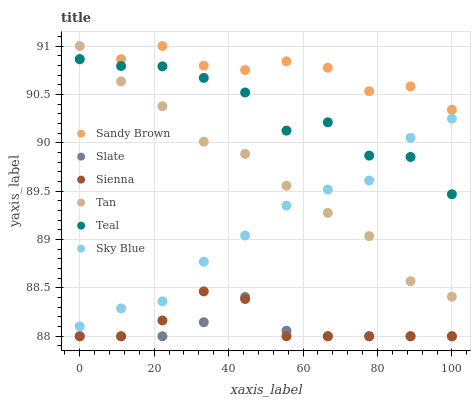Does Slate have the minimum area under the curve?
Answer yes or no. Yes. Does Sandy Brown have the maximum area under the curve?
Answer yes or no. Yes. Does Sienna have the minimum area under the curve?
Answer yes or no. No. Does Sienna have the maximum area under the curve?
Answer yes or no. No. Is Slate the smoothest?
Answer yes or no. Yes. Is Teal the roughest?
Answer yes or no. Yes. Is Sienna the smoothest?
Answer yes or no. No. Is Sienna the roughest?
Answer yes or no. No. Does Slate have the lowest value?
Answer yes or no. Yes. Does Teal have the lowest value?
Answer yes or no. No. Does Sandy Brown have the highest value?
Answer yes or no. Yes. Does Sienna have the highest value?
Answer yes or no. No. Is Slate less than Tan?
Answer yes or no. Yes. Is Sky Blue greater than Slate?
Answer yes or no. Yes. Does Slate intersect Sienna?
Answer yes or no. Yes. Is Slate less than Sienna?
Answer yes or no. No. Is Slate greater than Sienna?
Answer yes or no. No. Does Slate intersect Tan?
Answer yes or no. No. 